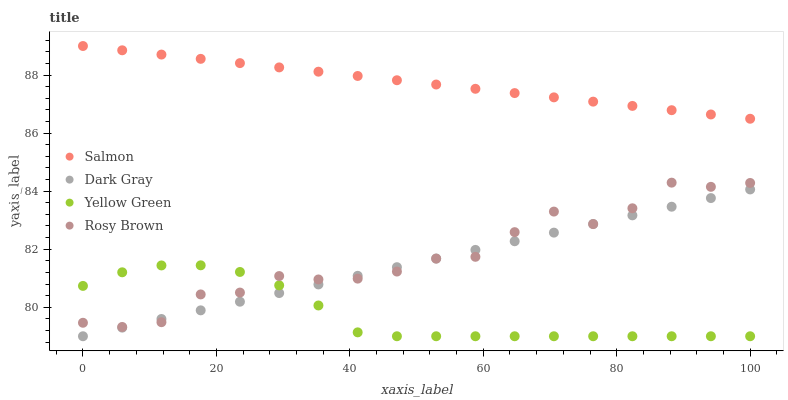Does Yellow Green have the minimum area under the curve?
Answer yes or no. Yes. Does Salmon have the maximum area under the curve?
Answer yes or no. Yes. Does Rosy Brown have the minimum area under the curve?
Answer yes or no. No. Does Rosy Brown have the maximum area under the curve?
Answer yes or no. No. Is Salmon the smoothest?
Answer yes or no. Yes. Is Rosy Brown the roughest?
Answer yes or no. Yes. Is Rosy Brown the smoothest?
Answer yes or no. No. Is Salmon the roughest?
Answer yes or no. No. Does Dark Gray have the lowest value?
Answer yes or no. Yes. Does Rosy Brown have the lowest value?
Answer yes or no. No. Does Salmon have the highest value?
Answer yes or no. Yes. Does Rosy Brown have the highest value?
Answer yes or no. No. Is Rosy Brown less than Salmon?
Answer yes or no. Yes. Is Salmon greater than Dark Gray?
Answer yes or no. Yes. Does Rosy Brown intersect Yellow Green?
Answer yes or no. Yes. Is Rosy Brown less than Yellow Green?
Answer yes or no. No. Is Rosy Brown greater than Yellow Green?
Answer yes or no. No. Does Rosy Brown intersect Salmon?
Answer yes or no. No. 